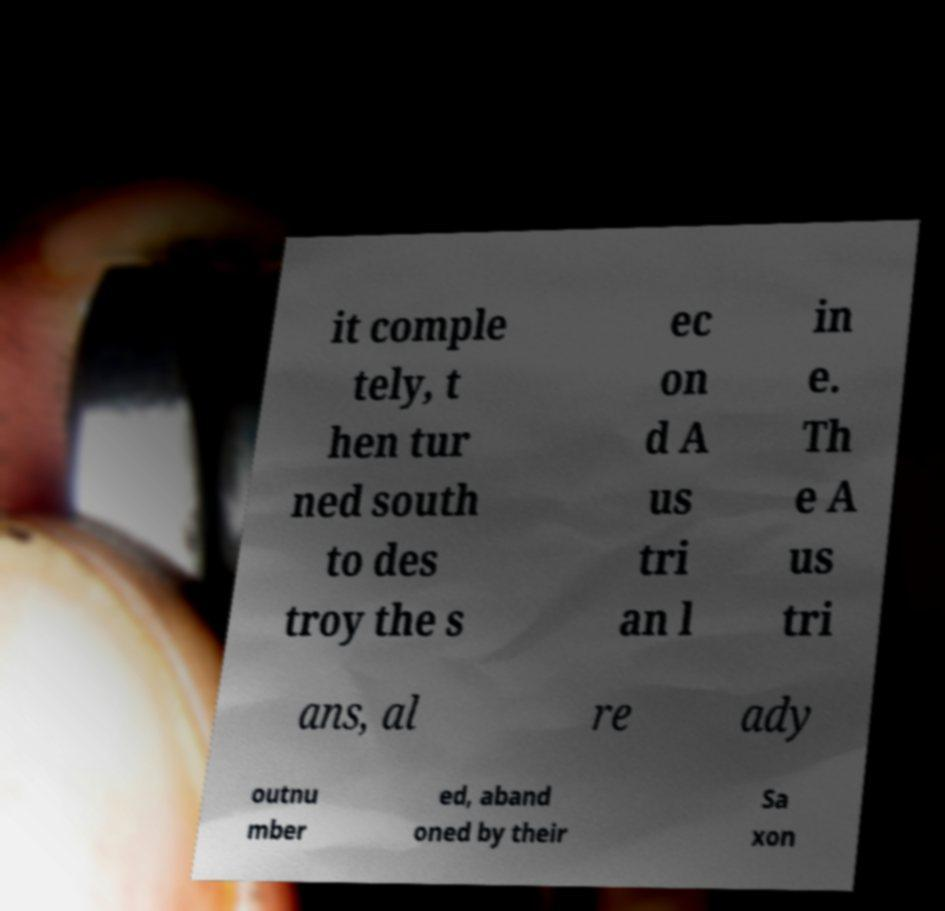For documentation purposes, I need the text within this image transcribed. Could you provide that? it comple tely, t hen tur ned south to des troy the s ec on d A us tri an l in e. Th e A us tri ans, al re ady outnu mber ed, aband oned by their Sa xon 